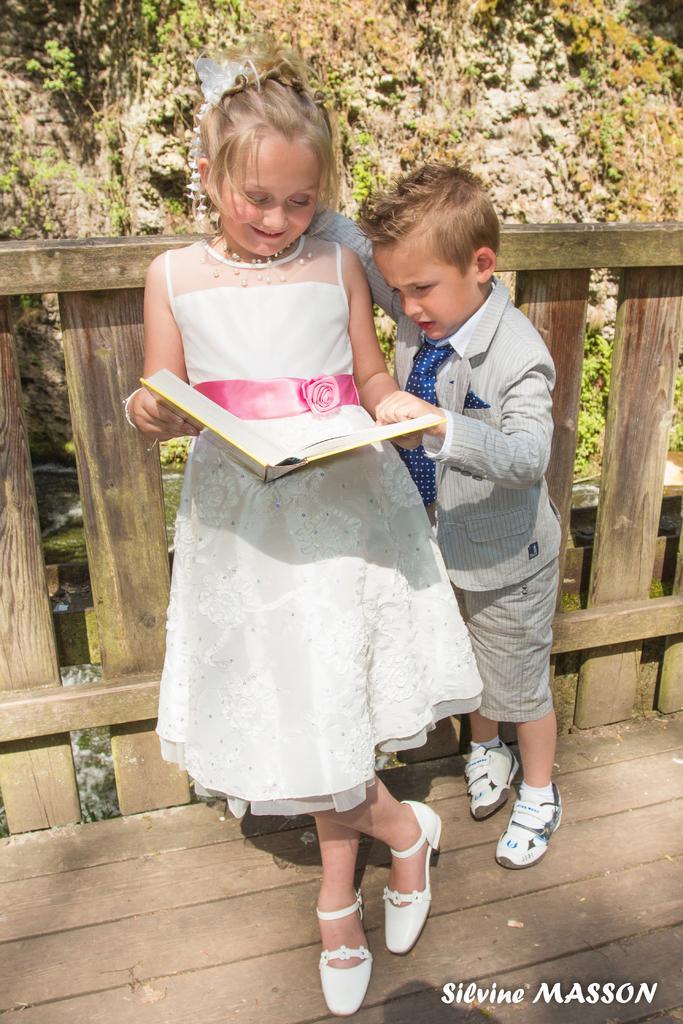Can you describe this image briefly? In this picture we can see small girl wearing white dress and holding the book in the hand and smiling. Beside we can see a small boy wearing a suit and looking into her book. Behind there is a wooden railing and some plants. 